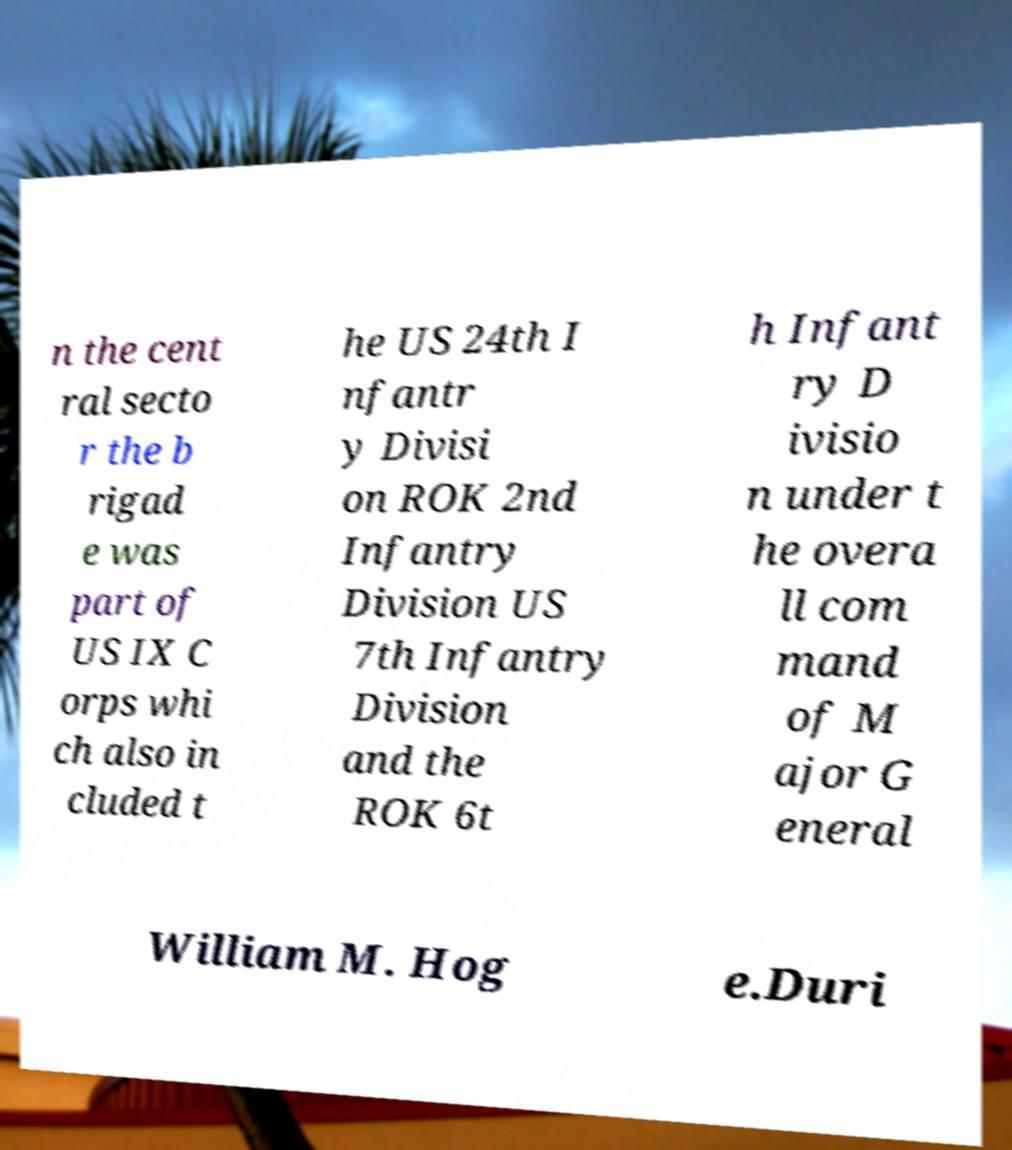What messages or text are displayed in this image? I need them in a readable, typed format. n the cent ral secto r the b rigad e was part of US IX C orps whi ch also in cluded t he US 24th I nfantr y Divisi on ROK 2nd Infantry Division US 7th Infantry Division and the ROK 6t h Infant ry D ivisio n under t he overa ll com mand of M ajor G eneral William M. Hog e.Duri 